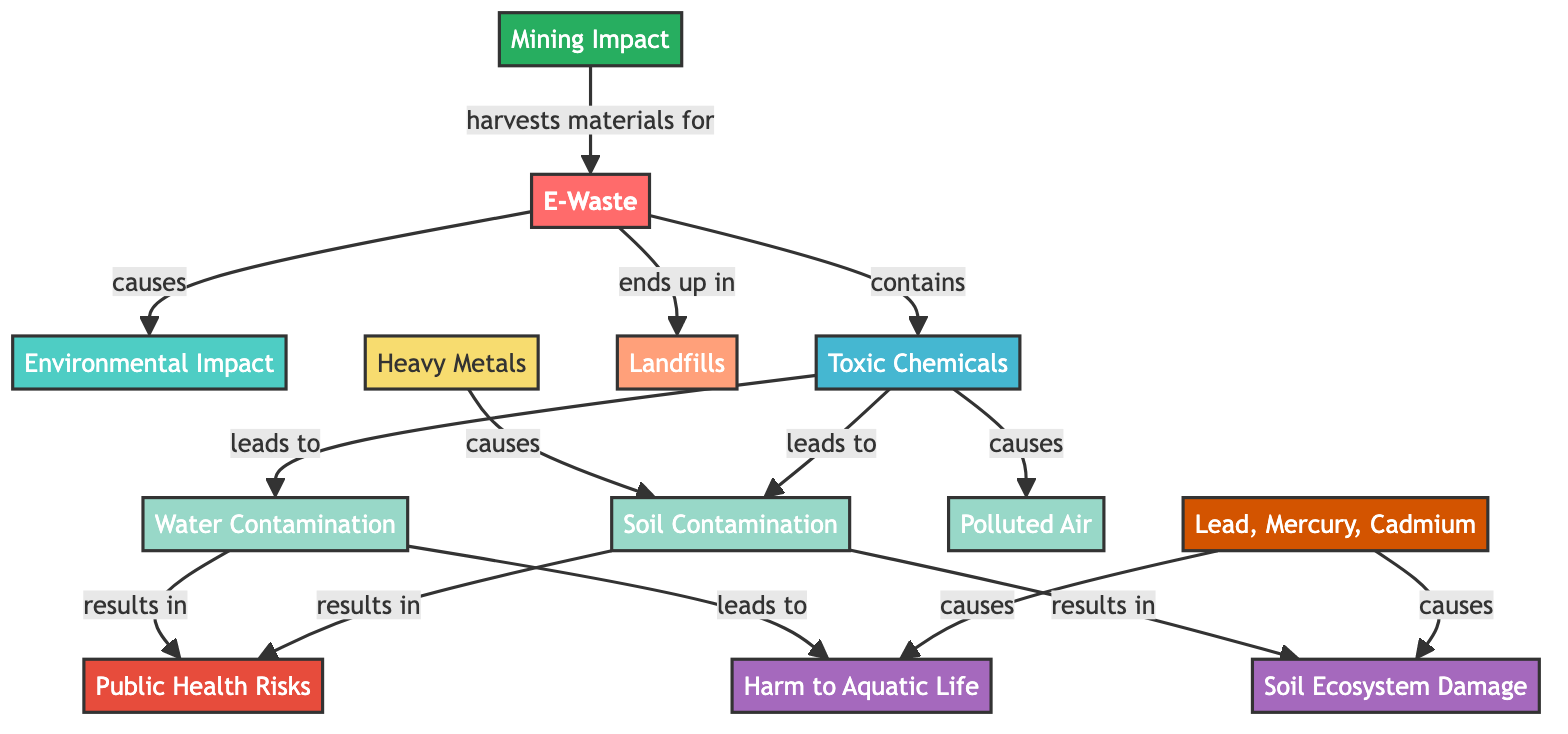What is the main subject of this diagram? The main subject highlighted in the diagram is titled "E-Waste." It is the starting point or primary focus that leads to various consequences outlined in the diagram.
Answer: E-Waste How many types of environmental impacts are shown? The diagram presents three types of environmental impacts resulting from e-waste, which are soil contamination, water contamination, and polluted air. By counting the result nodes connected to toxic chemicals, we find three distinct impacts.
Answer: 3 What toxic chemicals are specifically mentioned in the diagram? The diagram specifies three toxic chemicals: Lead, Mercury, and Cadmium. These chemicals are listed as a direct result of e-waste.
Answer: Lead, Mercury, Cadmium Which component leads to soil contamination? The component causing soil contamination is Heavy Metals. In the flow of the diagram, it connects directly to soil contamination, marking its influence on environmental degradation.
Answer: Heavy Metals What is the ultimate public health risk associated with contaminated soil or water? Contaminated soil or water leads to "Public Health Risks," as indicated in the diagram. Both soil and water contamination directly result in increased risks to public health, making it a critical concern.
Answer: Public Health Risks How does mining relate to e-waste? Mining is described as the activity that harvests materials for e-waste. This is indicated in the diagram, where mining is an origin that supplies raw materials for electronic devices, thus linking the two elements together.
Answer: Harvests materials for Which two outcomes stem from soil contamination? The two outcomes stemming from soil contamination are "Soil Ecosystem Damage" and "Public Health Risks." Following the connections in the diagram, these are the outcomes linked to soil contamination.
Answer: Soil Ecosystem Damage, Public Health Risks What does water contamination lead to regarding aquatic life? Water contamination leads to "Harm to Aquatic Life." The diagram shows a direct connection where water contamination impacts aquatic ecosystems negatively.
Answer: Harm to Aquatic Life Which type of destination is most commonly associated with e-waste? The destination most commonly associated with e-waste is "Landfills." This destination is specifically noted as the end point where e-waste is often disposed of, highlighting a significant environmental concern.
Answer: Landfills What is the relationship between toxic chemicals and polluted air? The relationship is that toxic chemicals lead to polluted air. In analyzing the flow, toxic chemicals are indicated to have a direct causative effect on the quality of air, marking a detrimental environmental consequence.
Answer: Leads to 